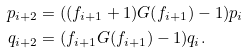Convert formula to latex. <formula><loc_0><loc_0><loc_500><loc_500>p _ { i + 2 } & = ( ( f _ { i + 1 } + 1 ) G ( f _ { i + 1 } ) - 1 ) p _ { i } \\ q _ { i + 2 } & = ( f _ { i + 1 } G ( f _ { i + 1 } ) - 1 ) q _ { i } .</formula> 